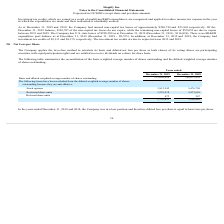From Shopify's financial document, Which 3 financial items were excluded from the diluted weighted average number of outstanding shares? The document contains multiple relevant values: Stock options, Restricted share units, Deferred share units. From the document: "Deferred share units 673 347 Stock options 3,812,242 5,476,790 Restricted share units 1,939,918 2,473,665..." Also, What financial information does the table show? reconciliation of the basic weighted average number of shares outstanding and the diluted weighted average number of shares outstanding. The document states: "The following table summarizes the reconciliation of the basic weighted average number of shares outstanding and the diluted weighted average number o..." Also, What is the number of deferred share units in 2019? According to the financial document, 673. The relevant text states: "Deferred share units 673 347..." Also, can you calculate: What is the average anti-dilutive stock options for 2018 and 2019? To answer this question, I need to perform calculations using the financial data. The calculation is: (3,812,242+5,476,790)/2, which equals 4644516. This is based on the information: "Stock options 3,812,242 5,476,790 Stock options 3,812,242 5,476,790..." The key data points involved are: 3,812,242, 5,476,790. Also, can you calculate: What is the average anti-dilutive restricted share units for 2018 and 2019? To answer this question, I need to perform calculations using the financial data. The calculation is: (1,939,918+2,473,665)/2, which equals 2206791.5. This is based on the information: "Restricted share units 1,939,918 2,473,665 Restricted share units 1,939,918 2,473,665..." The key data points involved are: 1,939,918, 2,473,665. Also, can you calculate: What is the average anti-dilutive deferred share units for 2018 and 2019? To answer this question, I need to perform calculations using the financial data. The calculation is: (673+347)/2, which equals 510. This is based on the information: "Deferred share units 673 347 Deferred share units 673 347..." The key data points involved are: 347, 673. 